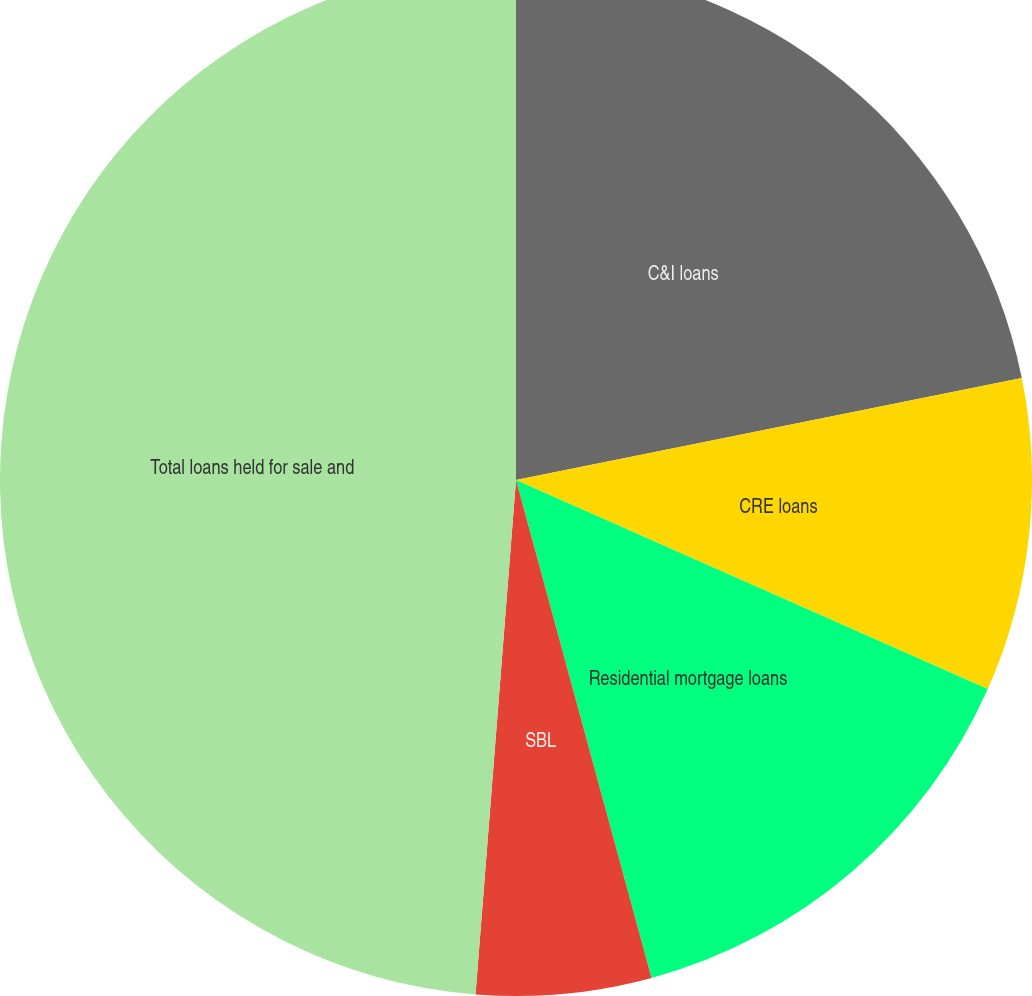Convert chart. <chart><loc_0><loc_0><loc_500><loc_500><pie_chart><fcel>C&I loans<fcel>CRE loans<fcel>Residential mortgage loans<fcel>SBL<fcel>Total loans held for sale and<nl><fcel>21.83%<fcel>9.81%<fcel>14.13%<fcel>5.48%<fcel>48.75%<nl></chart> 